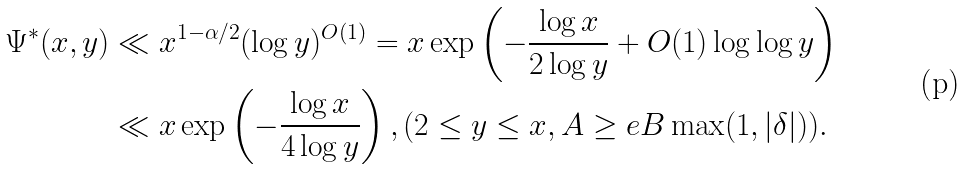<formula> <loc_0><loc_0><loc_500><loc_500>\Psi ^ { * } ( x , y ) & \ll x ^ { 1 - \alpha / 2 } ( \log y ) ^ { O ( 1 ) } = x \exp \left ( - \frac { \log x } { 2 \log y } + O ( 1 ) \log \log y \right ) \\ & \ll x \exp \left ( - \frac { \log x } { 4 \log y } \right ) , ( 2 \leq y \leq x , A \geq e B \max ( 1 , | \delta | ) ) .</formula> 